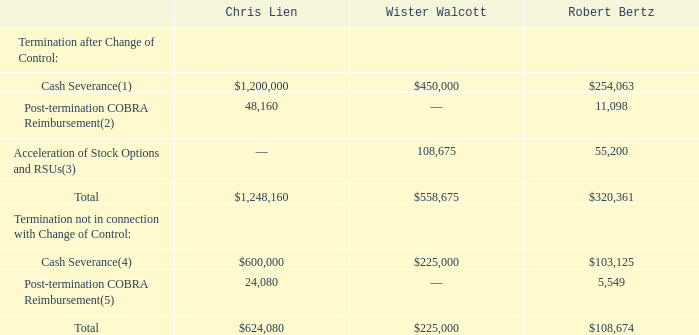The table below presents estimated payments and benefits that would have been provided to Messrs. Lien, Walcott and Bertz, assuming their respective qualifying terminations as of December 31, 2019. As a condition of receiving any severance benefits in connection with the change in control agreements, each named executive officer must execute a full waiver and release of all claims in our favor. In addition to the benefits described in the tables below, upon termination of employment each executive officer may be eligible for other benefits that are generally available to all salaried employees, such as life insurance, long-term disability, and 401(k) benefits.
(1) Mr. Lien would receive 18 months of base salary and 150% of his annual target bonus. Mr. Walcott would receive 12 months of base salary and 100% of his annual target bonus. Mr. Bertz would receive six months of base salary, 50% of his annual target bonus and the pro rata portion of his unpaid annual target bonus for the period of completed service.
(2) Mr. Lien would receive 18 months of COBRA benefits reimbursement and Mr. Bertz would receive six months of COBRA benefits reimbursement. Mr. Walcott elected not to receive benefits from the Company that would be eligible for continuation under COBRA. As a result, Mr. Walcott would not be eligible for post-termination COBRA benefits reimbursement.
(3) As of December 31, 2019, Mr. Walcott held a stock option with 13,006 unvested shares subject to such option with an exercise price of $17.15 per share. The exercise price of each of these stock options is greater than $1.38, the closing price of our common stock on The Nasdaq Global Market as of December 31, 2019. As of December 31, 2019, Mr. Walcott had 78,750 unvested RSUs and Mr. Bertz had 40,000 unvested RSUs.
(4) Mr. Lien would receive nine months of base salary and 75% of his annual target bonus; Mr. Walcott would receive six months of base salary and 50% of his target bonus; Mr. Bertz would receive three months of base salary and 25% of his target bonus.
(5) Mr. Lien would receive nine months of COBRA benefits reimbursement and Mr. Bertz would receive three months of COBRA benefits reimbursement. Mr. Walcott elected not to receive benefits from the Company that would be eligible for continuation under COBRA. As a result, Mr. Walcott would not be eligible for post-termination COBRA benefits reimbursement.
How many months of base salary would Mr Lien and Mr Walcott respectively receive as part of their cash severance? 18, 12. What percentage of their annual target bonus would Mr Lien and Mr Walcott respectively receive as part of their cash severance? 150%, 100%. How many months of COBRA benefits reimbursement would Mr Lien and Mr Bertz respectively receive as part of their post-termination COBRA Reimbursement? 18, 6. What is the total cash severance paid by the company if they were to terminate Chris Lien, Mister Walcott and Robert Bertz after Change of Control? 254,063  + 450,000 + 1,200,000 
Answer: 1904063. What is the value of Wister Walcott's cash severance as a percentage of Chris Lien's under termination after Change of Control?
Answer scale should be: percent. 450,000/1,200,000 
Answer: 37.5. Under termination after Change of Control, what is the average value of Chris Lien's and Robert Bertz's post-termination COBRA Reimbursement? (48,160 +  11,098)/2 
Answer: 29629. 